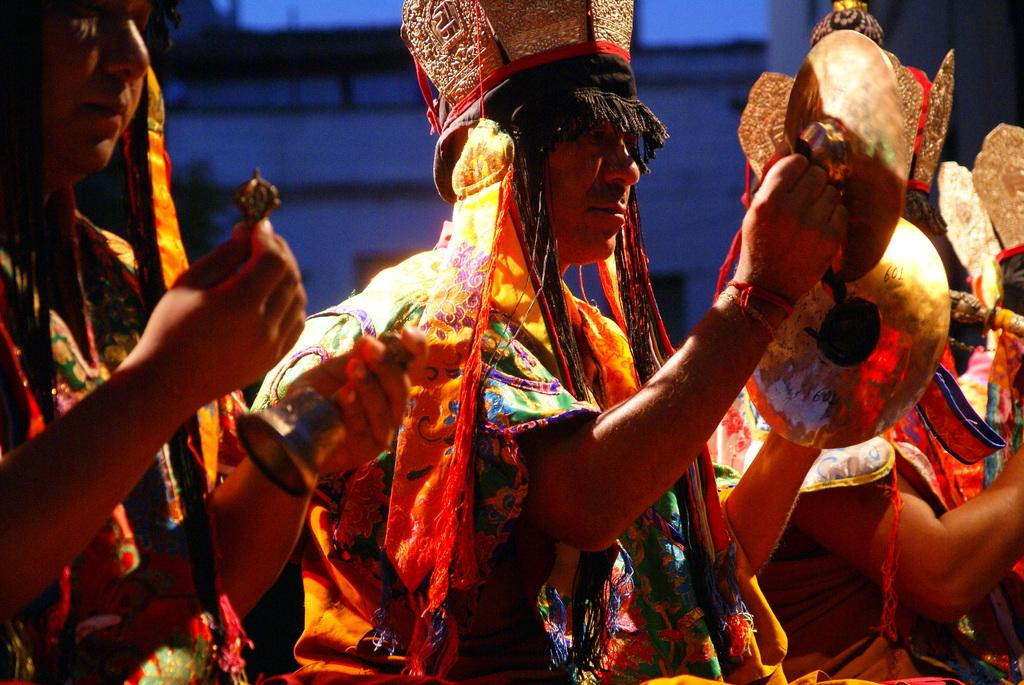Who or what is present in the image? There are people in the image. What are the people doing in the image? The people are holding musical instruments. How are the people dressed in the image? The people are wearing colorful costumes. What can be observed about the lighting or color of the background in the image? The background of the image is dark. How many vases can be seen on the stage in the image? There are no vases present in the image; it features people holding musical instruments and wearing colorful costumes. What type of class is being conducted in the image? There is no indication of a class being conducted in the image; it shows people playing musical instruments. 